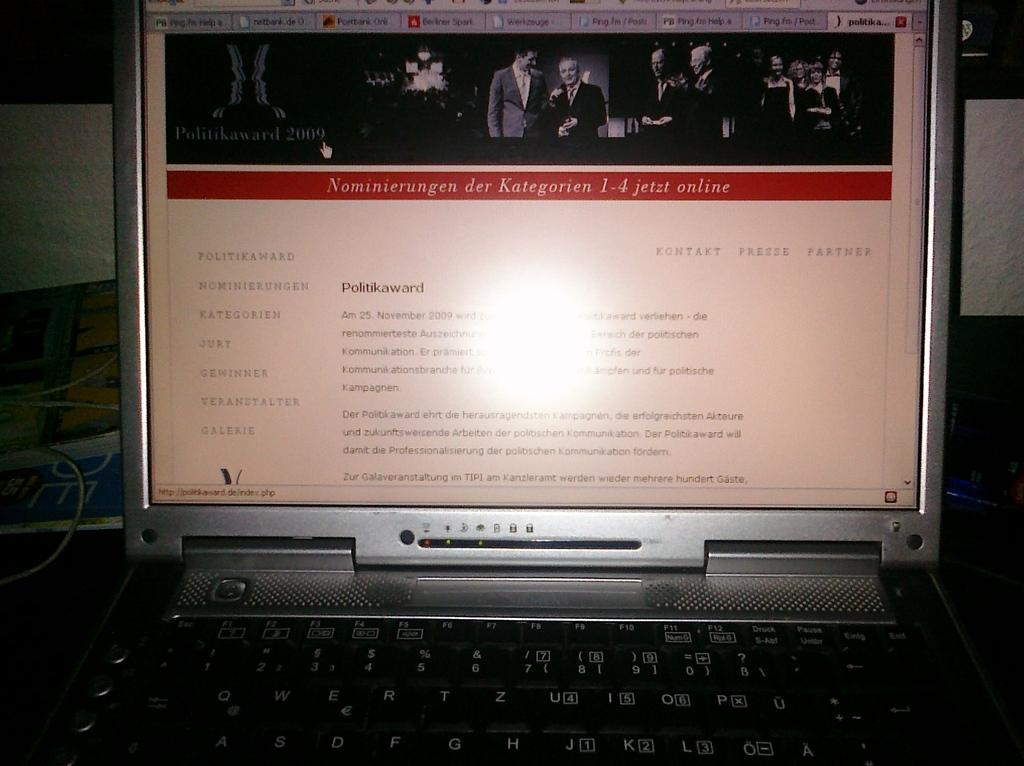<image>
Relay a brief, clear account of the picture shown. Laptop monitor showing a screen that says Politikaward. " 